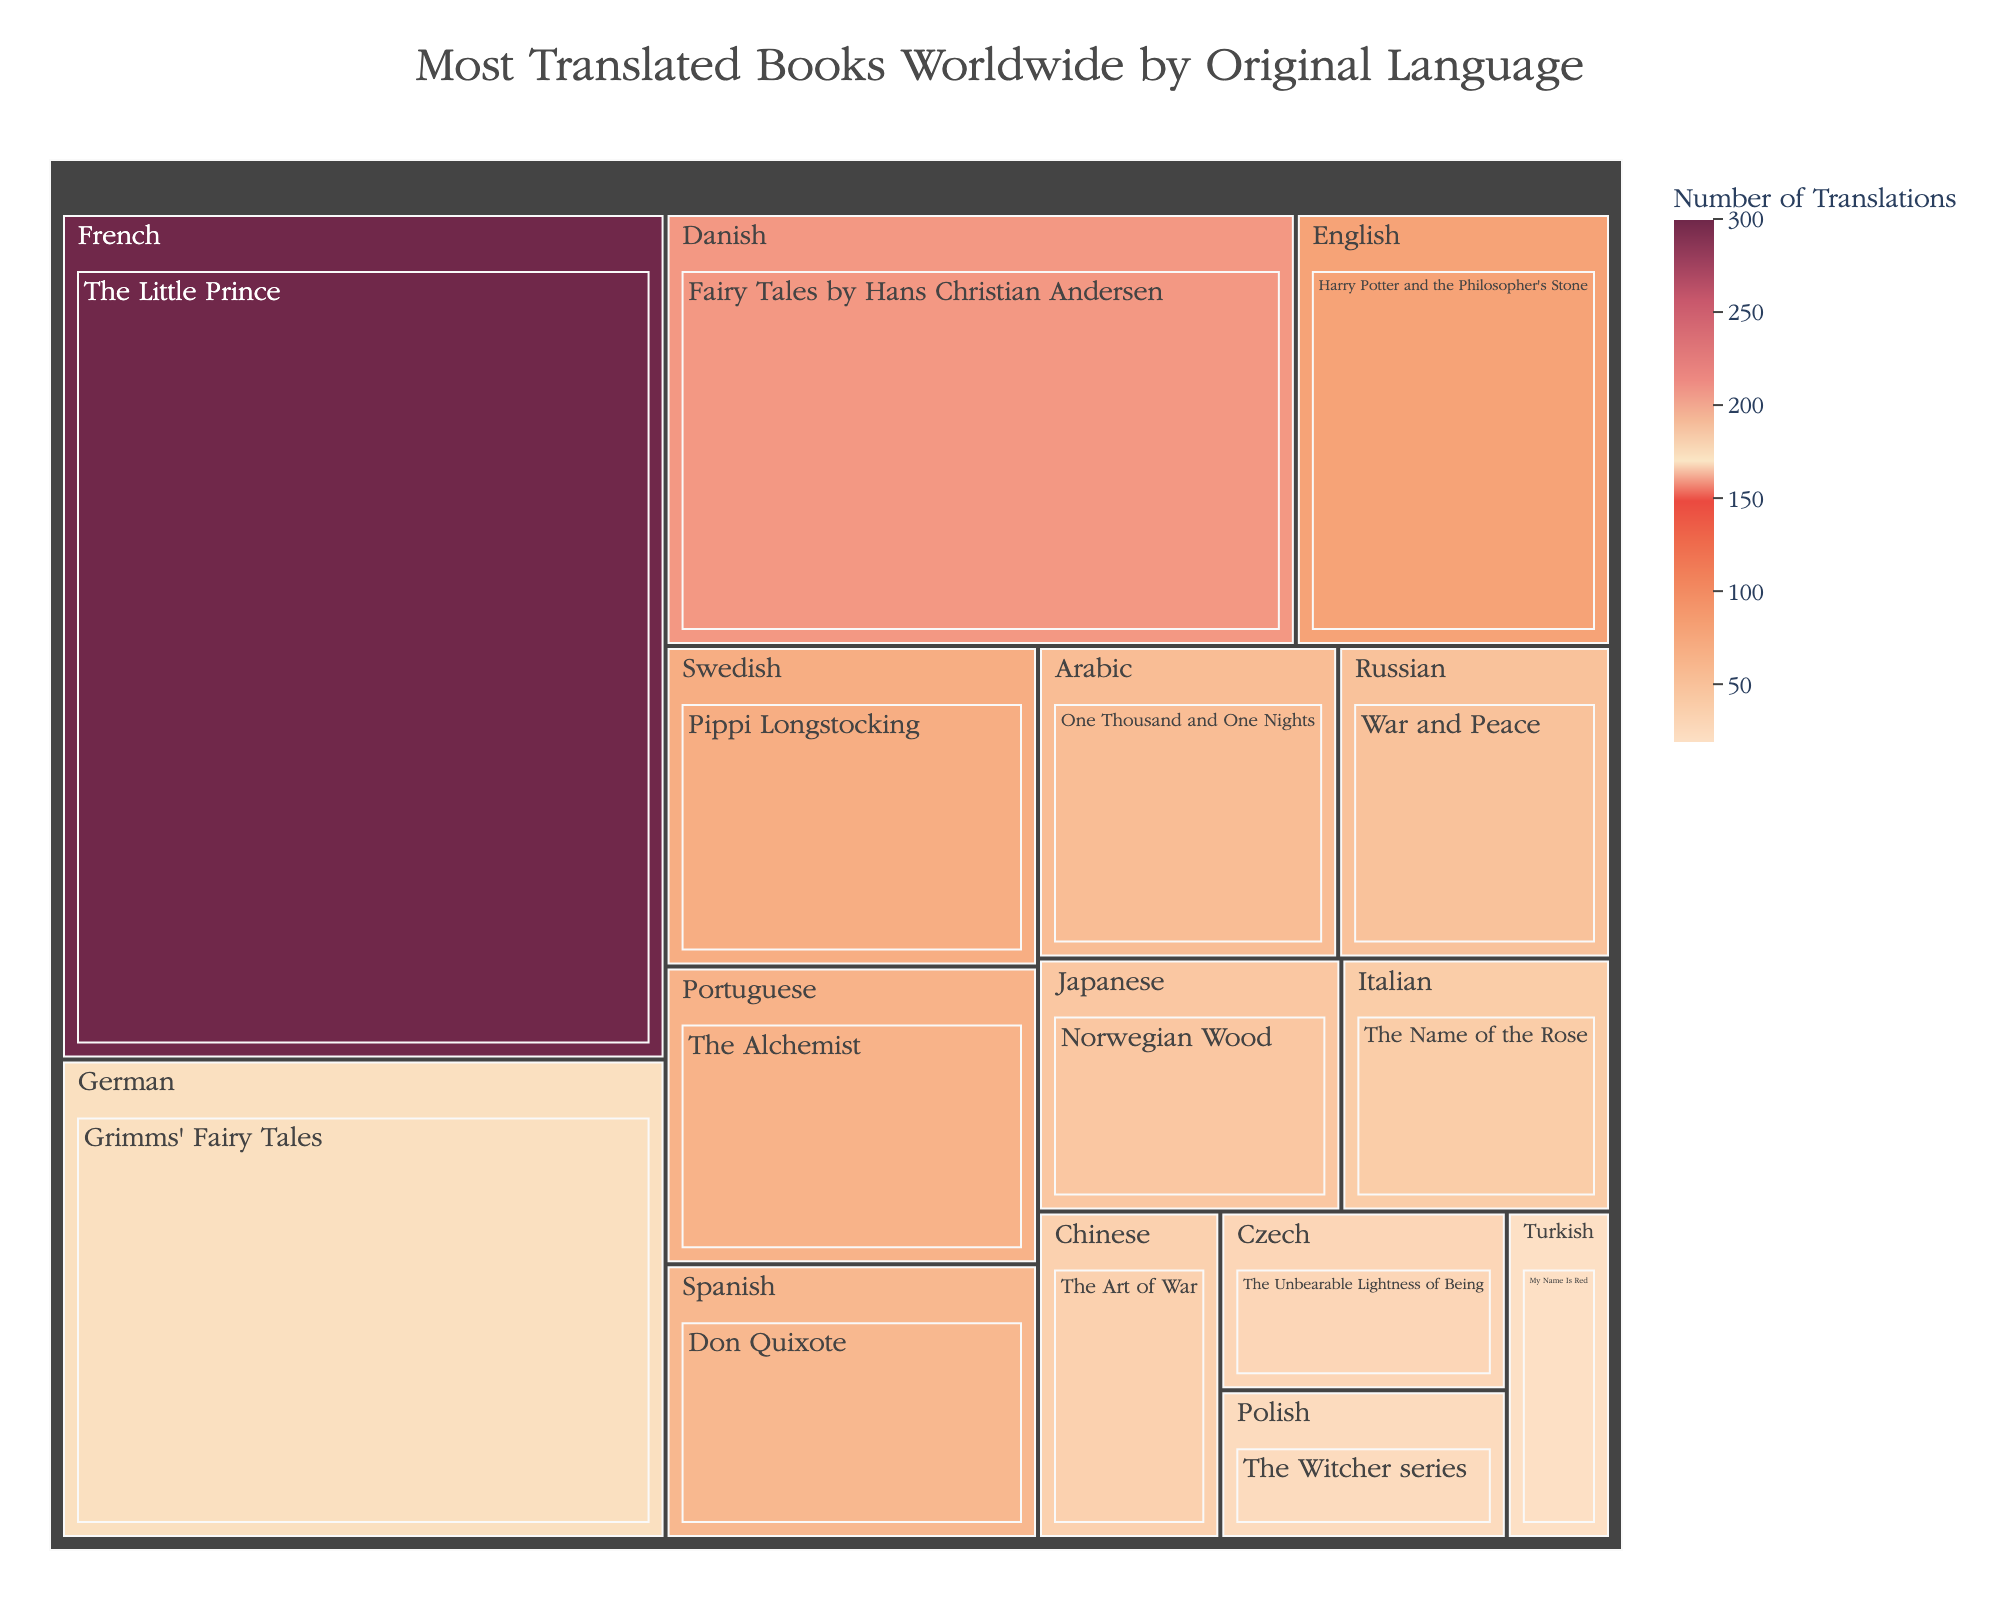Which book has the highest number of translations? By looking at the largest segment in the treemap, which is colored the darkest, you can see that "The Little Prince" has the highest number of translations.
Answer: The Little Prince What is the title of the chart? The chart title is usually displayed prominently at the top of the figure. It can be read directly from there.
Answer: Most Translated Books Worldwide by Original Language Which language has the most books in the chart? Scan the chart to count the number of books for each language. English has two distinct entries in the figure.
Answer: English How many translations does "Harry Potter and the Philosopher's Stone" have? Find the segment labeled "Harry Potter and the Philosopher's Stone" and check its value. It shows 80 translations.
Answer: 80 What is the sum of translations for books originally in French and German? Locate the values for the books in French (300 for "The Little Prince") and German (170 for "Grimms' Fairy Tales"). Add these numbers: 300 + 170.
Answer: 470 Which book has fewer translations: "Norwegian Wood" or "War and Peace"? Compare the values for "Norwegian Wood" (45 translations) and "War and Peace" (50 translations). "Norwegian Wood" has fewer translations.
Answer: Norwegian Wood What color is used to represent the most translated book? The darkest or most intense color in the treemap represents the book with the highest number of translations.
Answer: Darkest shade of the color scale used Which book originally in Russian has 50 translations? Identify the segment associated with the Russian language and then check the book with 50 translations. It's "War and Peace."
Answer: War and Peace What is the average number of translations for the books listed in the chart? Sum all given translations and divide by the number of books. (300 + 80 + 60 + 160 + 170 + 50 + 40 + 70 + 45 + 65 + 55 + 35 + 30 + 25 + 20) / 15 books. This sums to 1205. The average is 1205 / 15.
Answer: 80.33 Which book translated from Italian has the specific number of translations provided? The book translated from Italian is "The Name of the Rose," with 40 translations. Locate the Italian segment, and you’ll find the corresponding book and its translations.
Answer: The Name of the Rose 